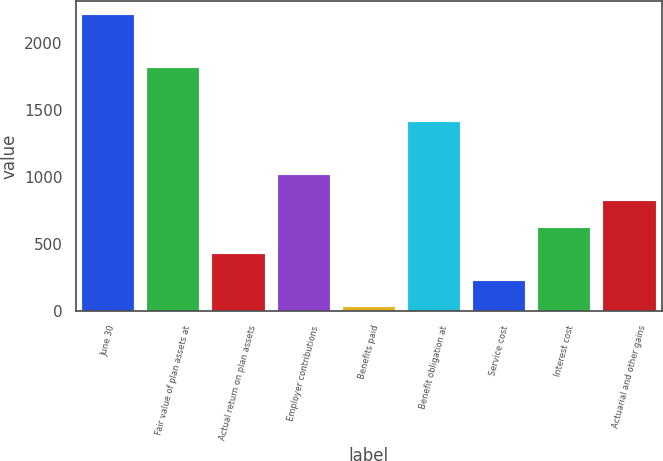<chart> <loc_0><loc_0><loc_500><loc_500><bar_chart><fcel>June 30<fcel>Fair value of plan assets at<fcel>Actual return on plan assets<fcel>Employer contributions<fcel>Benefits paid<fcel>Benefit obligation at<fcel>Service cost<fcel>Interest cost<fcel>Actuarial and other gains<nl><fcel>2205.83<fcel>1810.17<fcel>425.36<fcel>1018.85<fcel>29.7<fcel>1414.51<fcel>227.53<fcel>623.19<fcel>821.02<nl></chart> 